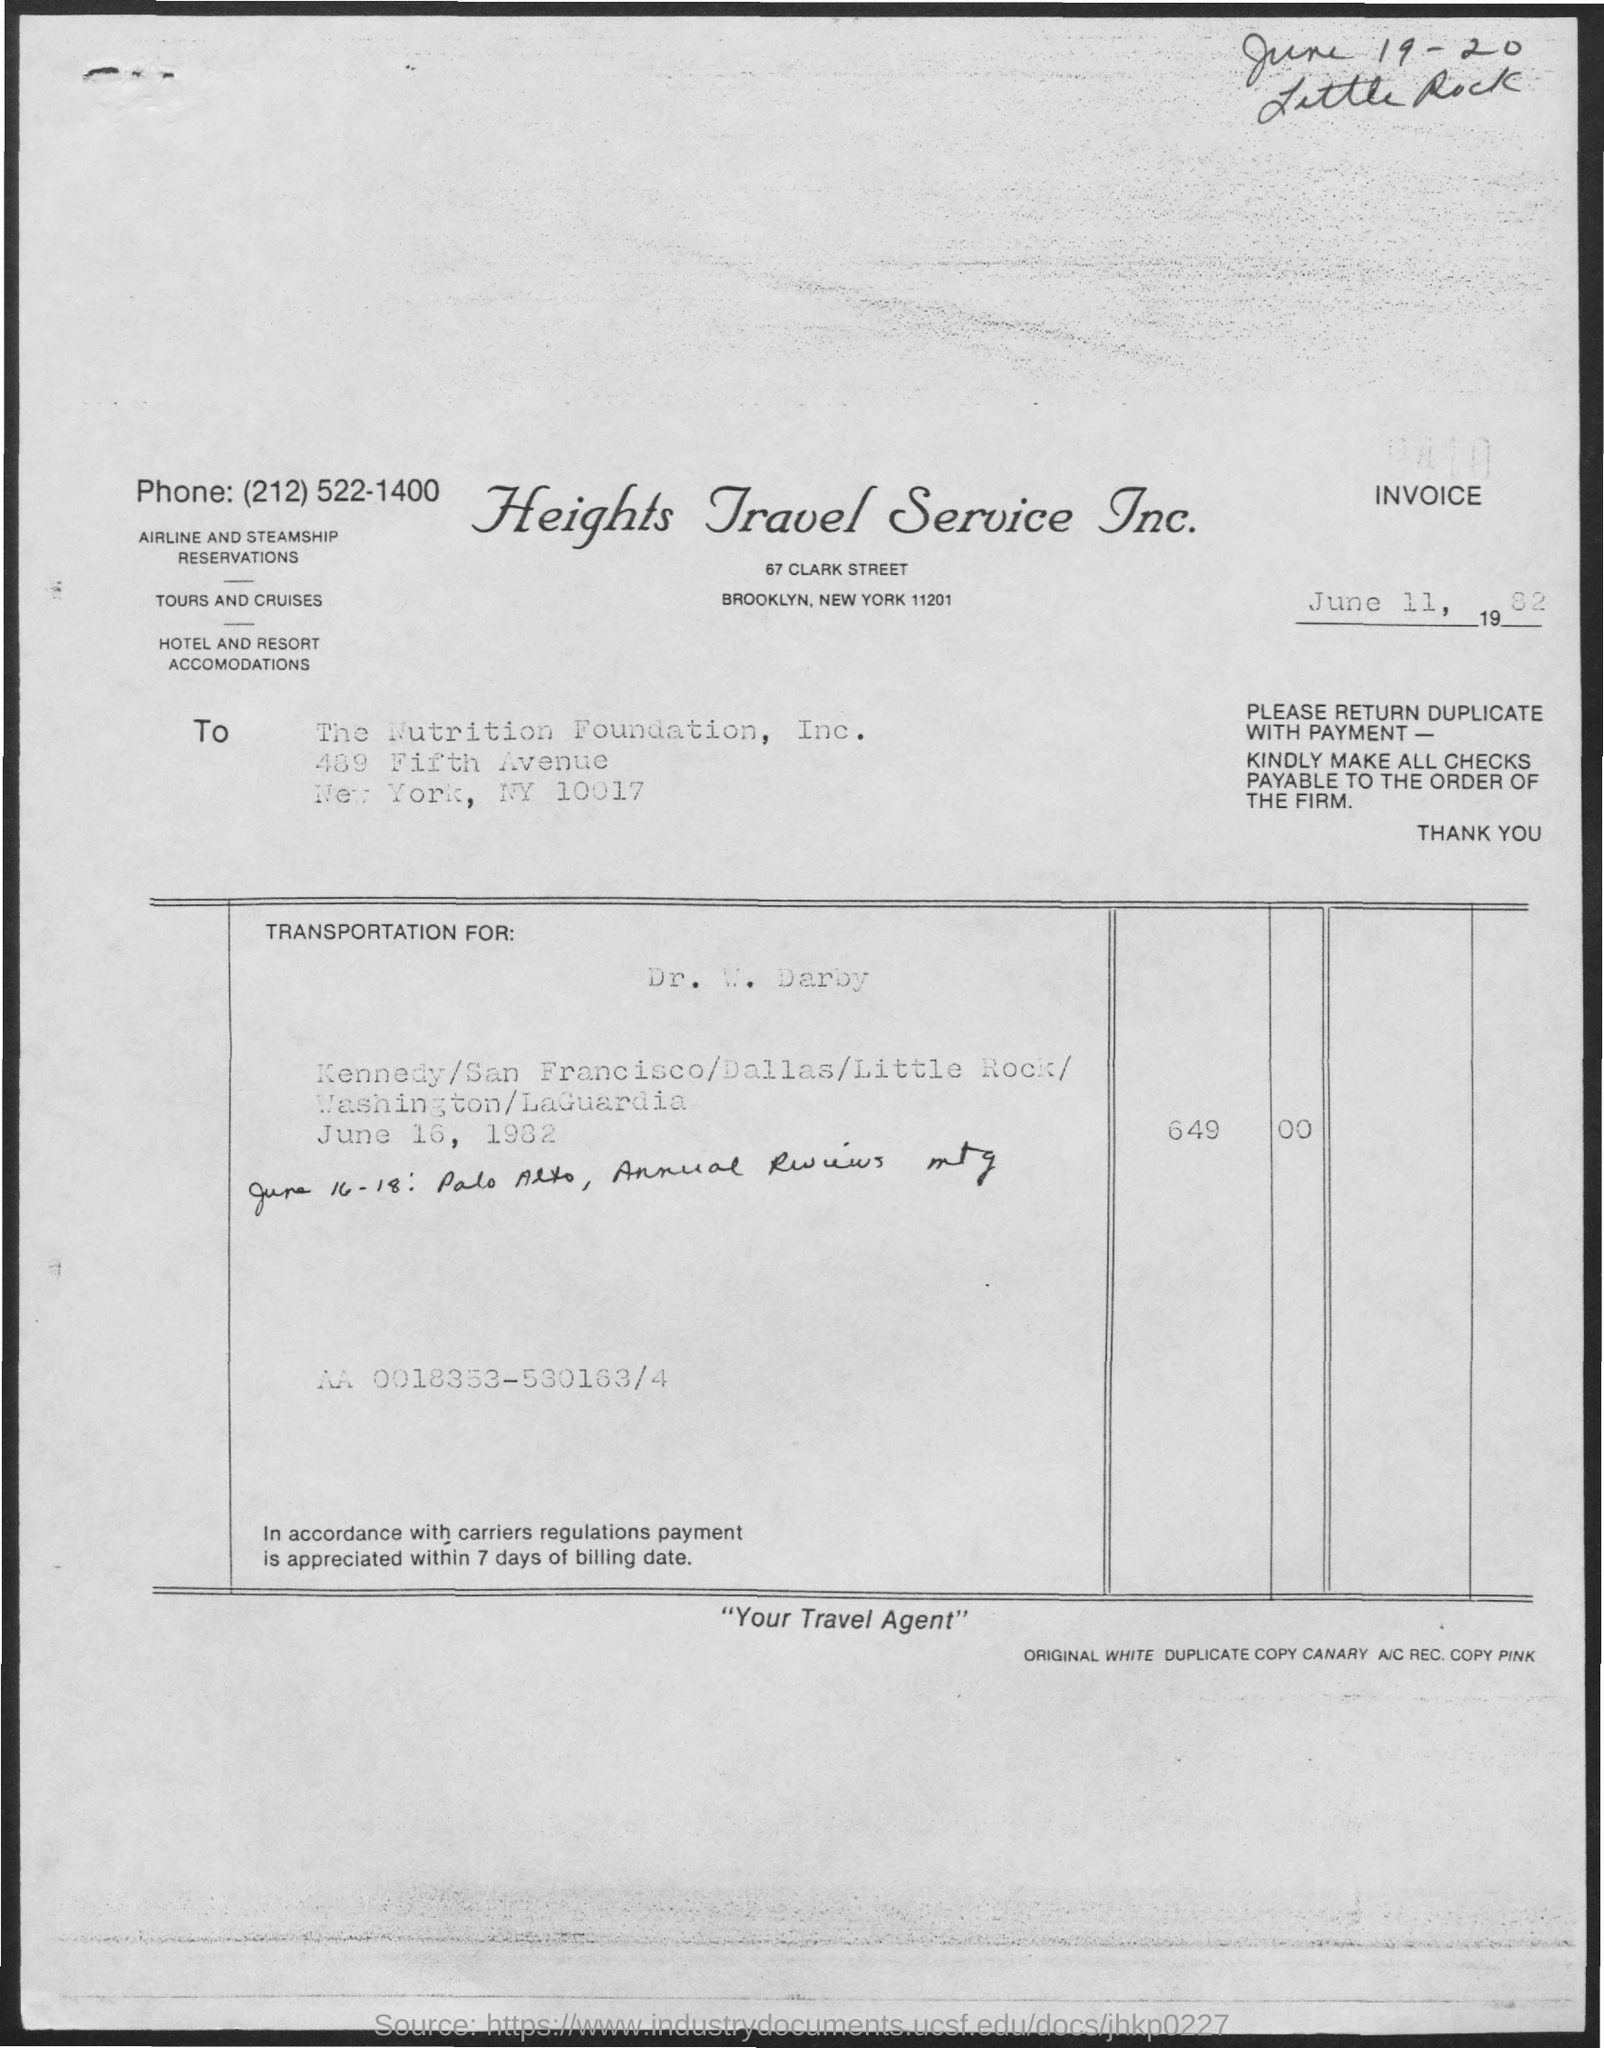Identify some key points in this picture. The name of the travel service is Heights Travel Service Inc. 